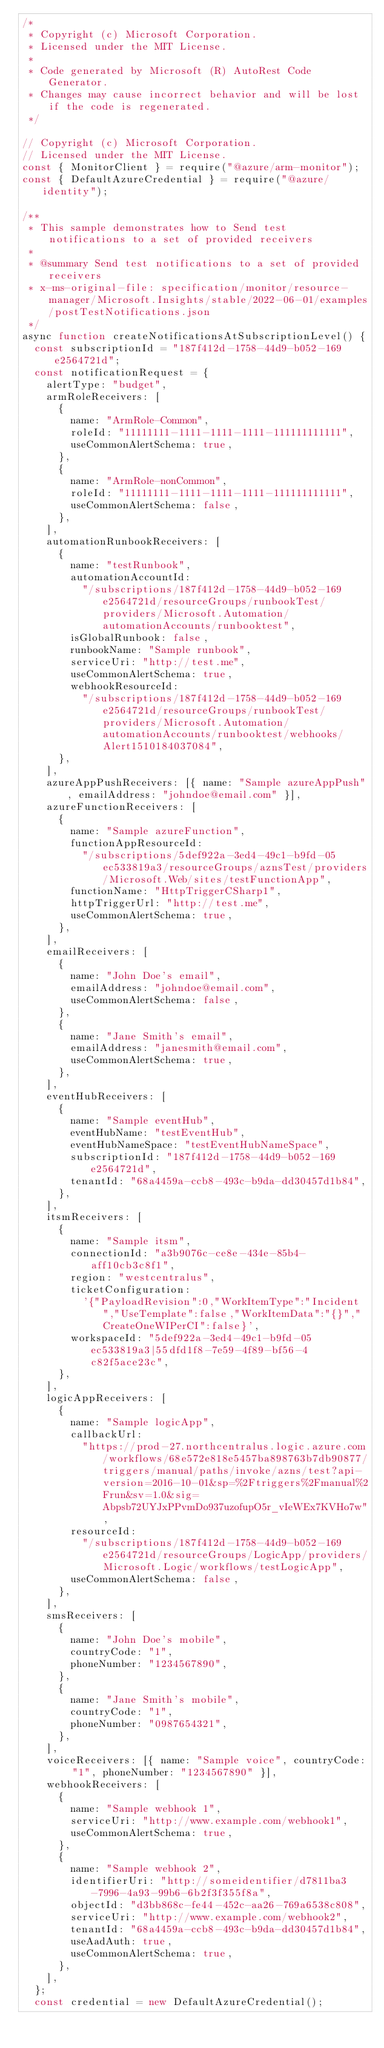Convert code to text. <code><loc_0><loc_0><loc_500><loc_500><_JavaScript_>/*
 * Copyright (c) Microsoft Corporation.
 * Licensed under the MIT License.
 *
 * Code generated by Microsoft (R) AutoRest Code Generator.
 * Changes may cause incorrect behavior and will be lost if the code is regenerated.
 */

// Copyright (c) Microsoft Corporation.
// Licensed under the MIT License.
const { MonitorClient } = require("@azure/arm-monitor");
const { DefaultAzureCredential } = require("@azure/identity");

/**
 * This sample demonstrates how to Send test notifications to a set of provided receivers
 *
 * @summary Send test notifications to a set of provided receivers
 * x-ms-original-file: specification/monitor/resource-manager/Microsoft.Insights/stable/2022-06-01/examples/postTestNotifications.json
 */
async function createNotificationsAtSubscriptionLevel() {
  const subscriptionId = "187f412d-1758-44d9-b052-169e2564721d";
  const notificationRequest = {
    alertType: "budget",
    armRoleReceivers: [
      {
        name: "ArmRole-Common",
        roleId: "11111111-1111-1111-1111-111111111111",
        useCommonAlertSchema: true,
      },
      {
        name: "ArmRole-nonCommon",
        roleId: "11111111-1111-1111-1111-111111111111",
        useCommonAlertSchema: false,
      },
    ],
    automationRunbookReceivers: [
      {
        name: "testRunbook",
        automationAccountId:
          "/subscriptions/187f412d-1758-44d9-b052-169e2564721d/resourceGroups/runbookTest/providers/Microsoft.Automation/automationAccounts/runbooktest",
        isGlobalRunbook: false,
        runbookName: "Sample runbook",
        serviceUri: "http://test.me",
        useCommonAlertSchema: true,
        webhookResourceId:
          "/subscriptions/187f412d-1758-44d9-b052-169e2564721d/resourceGroups/runbookTest/providers/Microsoft.Automation/automationAccounts/runbooktest/webhooks/Alert1510184037084",
      },
    ],
    azureAppPushReceivers: [{ name: "Sample azureAppPush", emailAddress: "johndoe@email.com" }],
    azureFunctionReceivers: [
      {
        name: "Sample azureFunction",
        functionAppResourceId:
          "/subscriptions/5def922a-3ed4-49c1-b9fd-05ec533819a3/resourceGroups/aznsTest/providers/Microsoft.Web/sites/testFunctionApp",
        functionName: "HttpTriggerCSharp1",
        httpTriggerUrl: "http://test.me",
        useCommonAlertSchema: true,
      },
    ],
    emailReceivers: [
      {
        name: "John Doe's email",
        emailAddress: "johndoe@email.com",
        useCommonAlertSchema: false,
      },
      {
        name: "Jane Smith's email",
        emailAddress: "janesmith@email.com",
        useCommonAlertSchema: true,
      },
    ],
    eventHubReceivers: [
      {
        name: "Sample eventHub",
        eventHubName: "testEventHub",
        eventHubNameSpace: "testEventHubNameSpace",
        subscriptionId: "187f412d-1758-44d9-b052-169e2564721d",
        tenantId: "68a4459a-ccb8-493c-b9da-dd30457d1b84",
      },
    ],
    itsmReceivers: [
      {
        name: "Sample itsm",
        connectionId: "a3b9076c-ce8e-434e-85b4-aff10cb3c8f1",
        region: "westcentralus",
        ticketConfiguration:
          '{"PayloadRevision":0,"WorkItemType":"Incident","UseTemplate":false,"WorkItemData":"{}","CreateOneWIPerCI":false}',
        workspaceId: "5def922a-3ed4-49c1-b9fd-05ec533819a3|55dfd1f8-7e59-4f89-bf56-4c82f5ace23c",
      },
    ],
    logicAppReceivers: [
      {
        name: "Sample logicApp",
        callbackUrl:
          "https://prod-27.northcentralus.logic.azure.com/workflows/68e572e818e5457ba898763b7db90877/triggers/manual/paths/invoke/azns/test?api-version=2016-10-01&sp=%2Ftriggers%2Fmanual%2Frun&sv=1.0&sig=Abpsb72UYJxPPvmDo937uzofupO5r_vIeWEx7KVHo7w",
        resourceId:
          "/subscriptions/187f412d-1758-44d9-b052-169e2564721d/resourceGroups/LogicApp/providers/Microsoft.Logic/workflows/testLogicApp",
        useCommonAlertSchema: false,
      },
    ],
    smsReceivers: [
      {
        name: "John Doe's mobile",
        countryCode: "1",
        phoneNumber: "1234567890",
      },
      {
        name: "Jane Smith's mobile",
        countryCode: "1",
        phoneNumber: "0987654321",
      },
    ],
    voiceReceivers: [{ name: "Sample voice", countryCode: "1", phoneNumber: "1234567890" }],
    webhookReceivers: [
      {
        name: "Sample webhook 1",
        serviceUri: "http://www.example.com/webhook1",
        useCommonAlertSchema: true,
      },
      {
        name: "Sample webhook 2",
        identifierUri: "http://someidentifier/d7811ba3-7996-4a93-99b6-6b2f3f355f8a",
        objectId: "d3bb868c-fe44-452c-aa26-769a6538c808",
        serviceUri: "http://www.example.com/webhook2",
        tenantId: "68a4459a-ccb8-493c-b9da-dd30457d1b84",
        useAadAuth: true,
        useCommonAlertSchema: true,
      },
    ],
  };
  const credential = new DefaultAzureCredential();</code> 